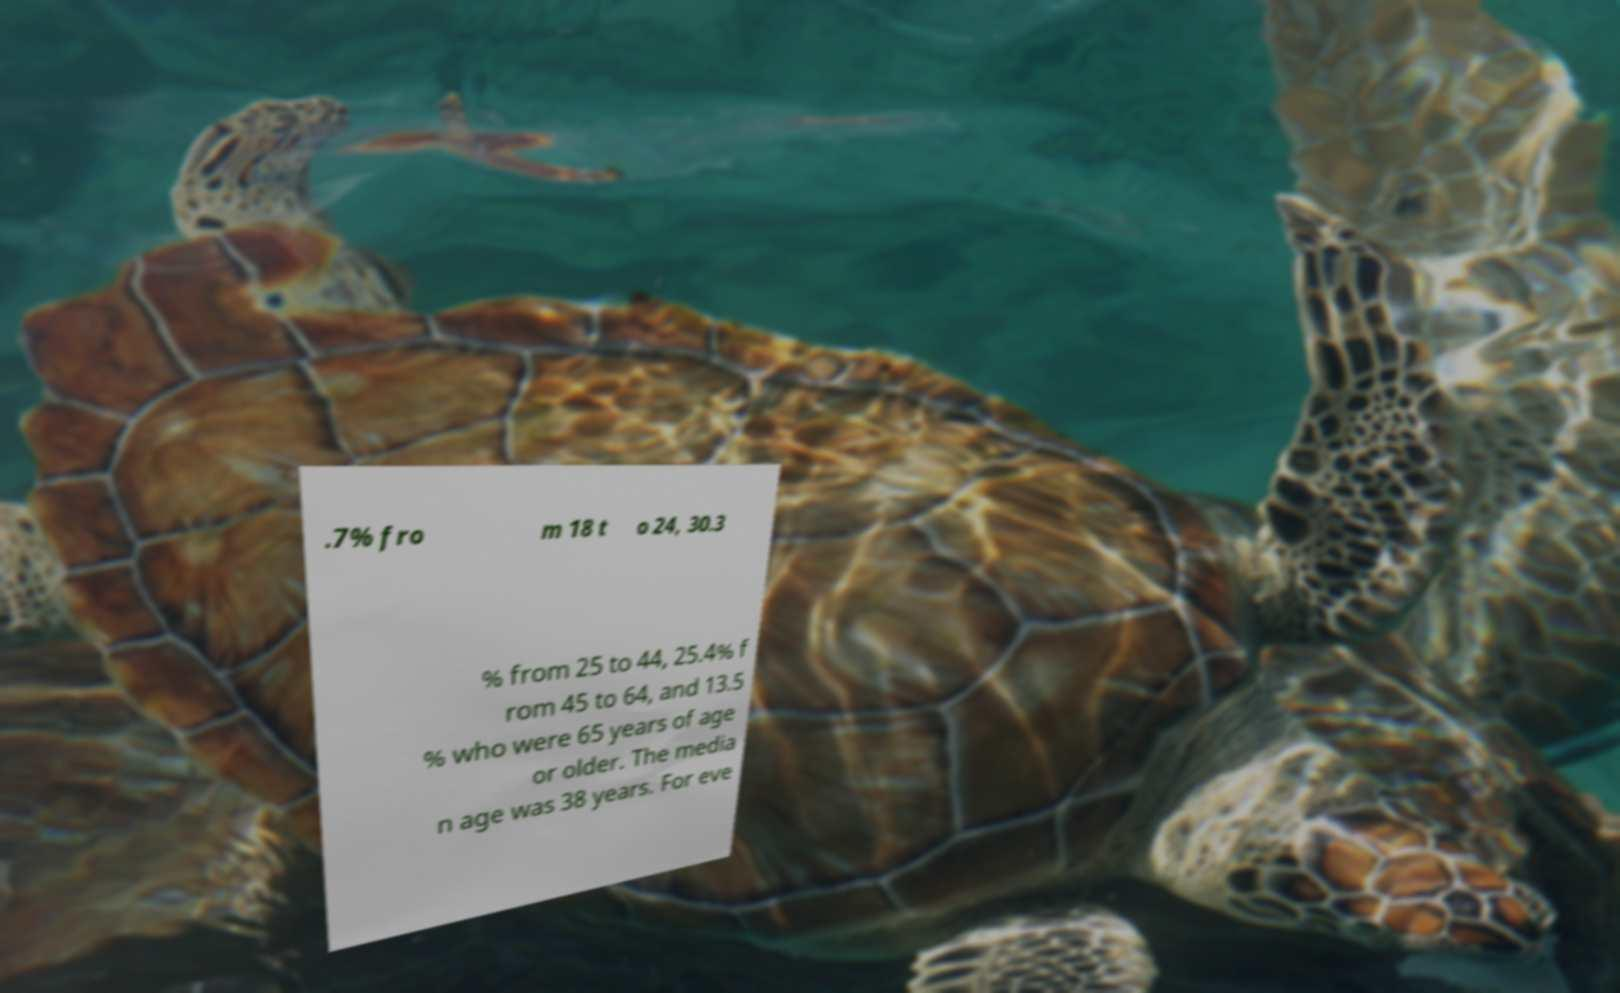Can you accurately transcribe the text from the provided image for me? .7% fro m 18 t o 24, 30.3 % from 25 to 44, 25.4% f rom 45 to 64, and 13.5 % who were 65 years of age or older. The media n age was 38 years. For eve 